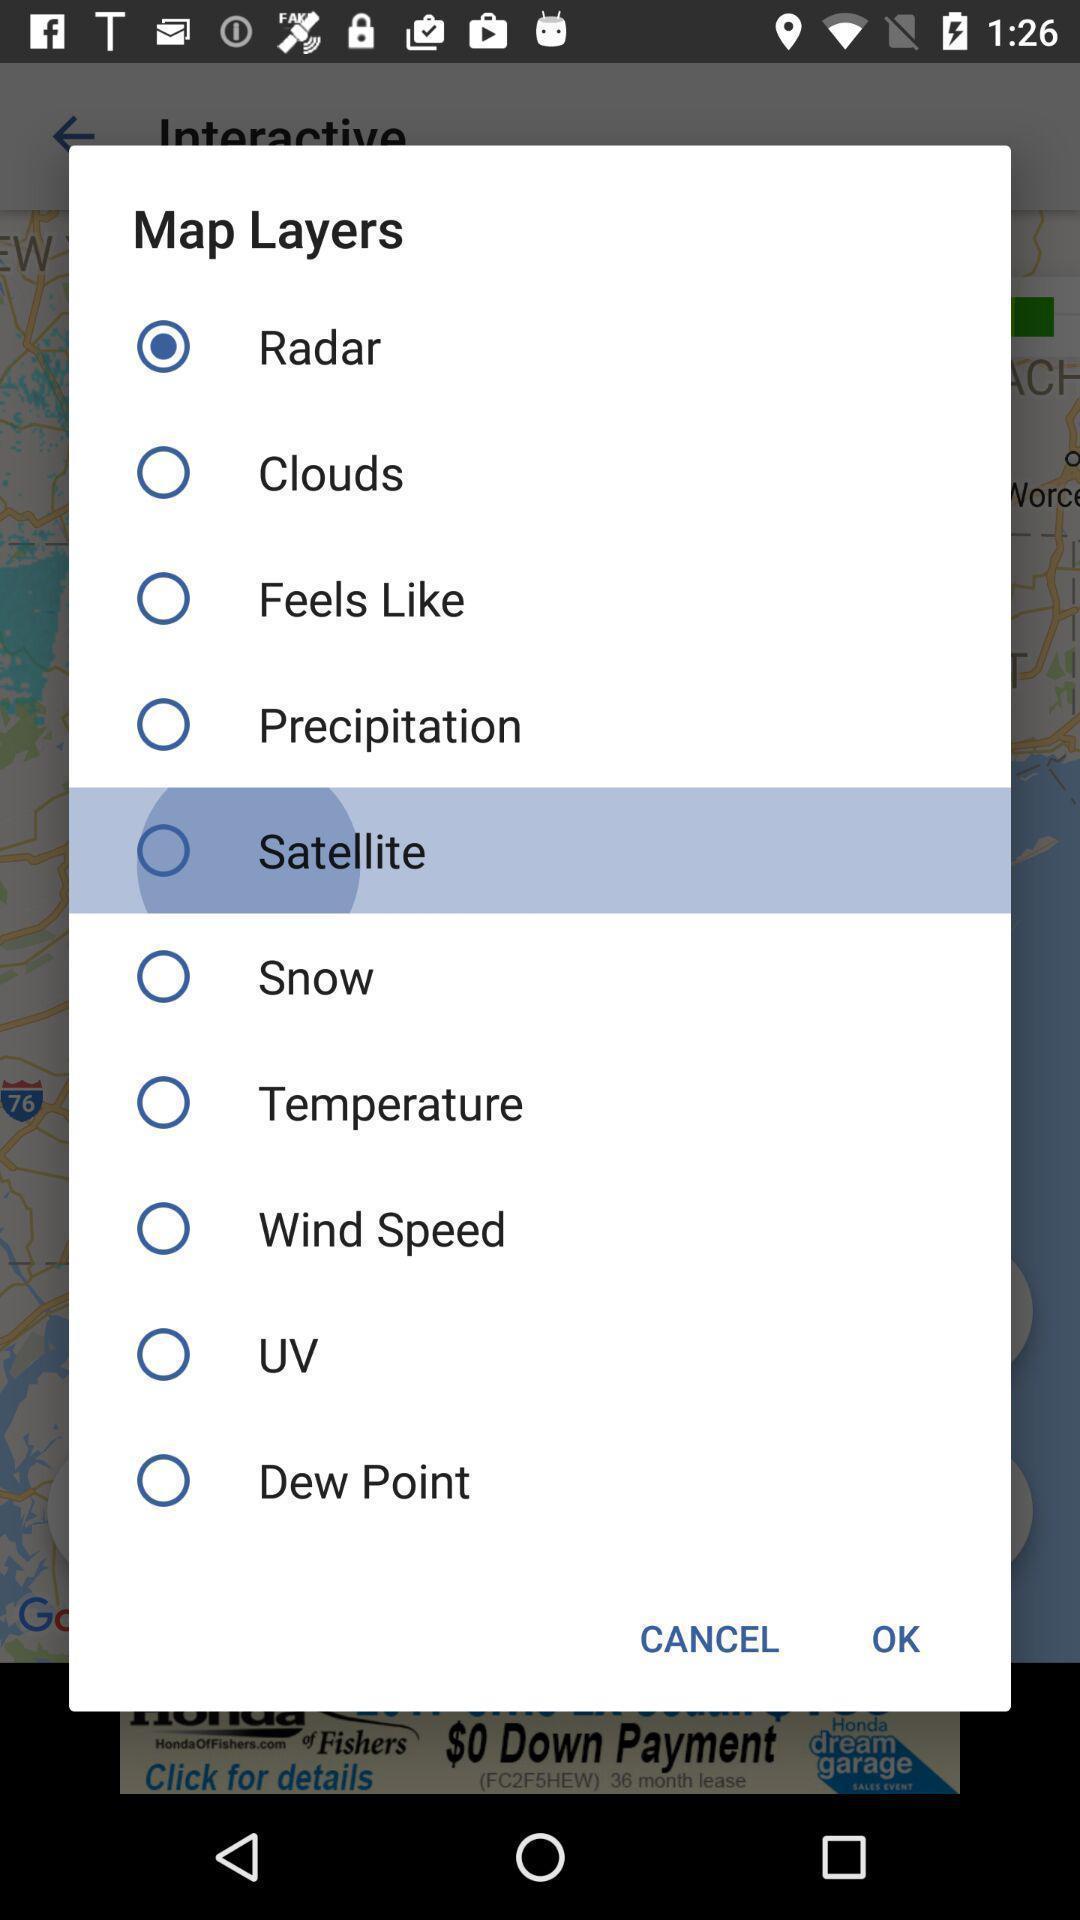Provide a textual representation of this image. Pop-up shows list of map layers. 